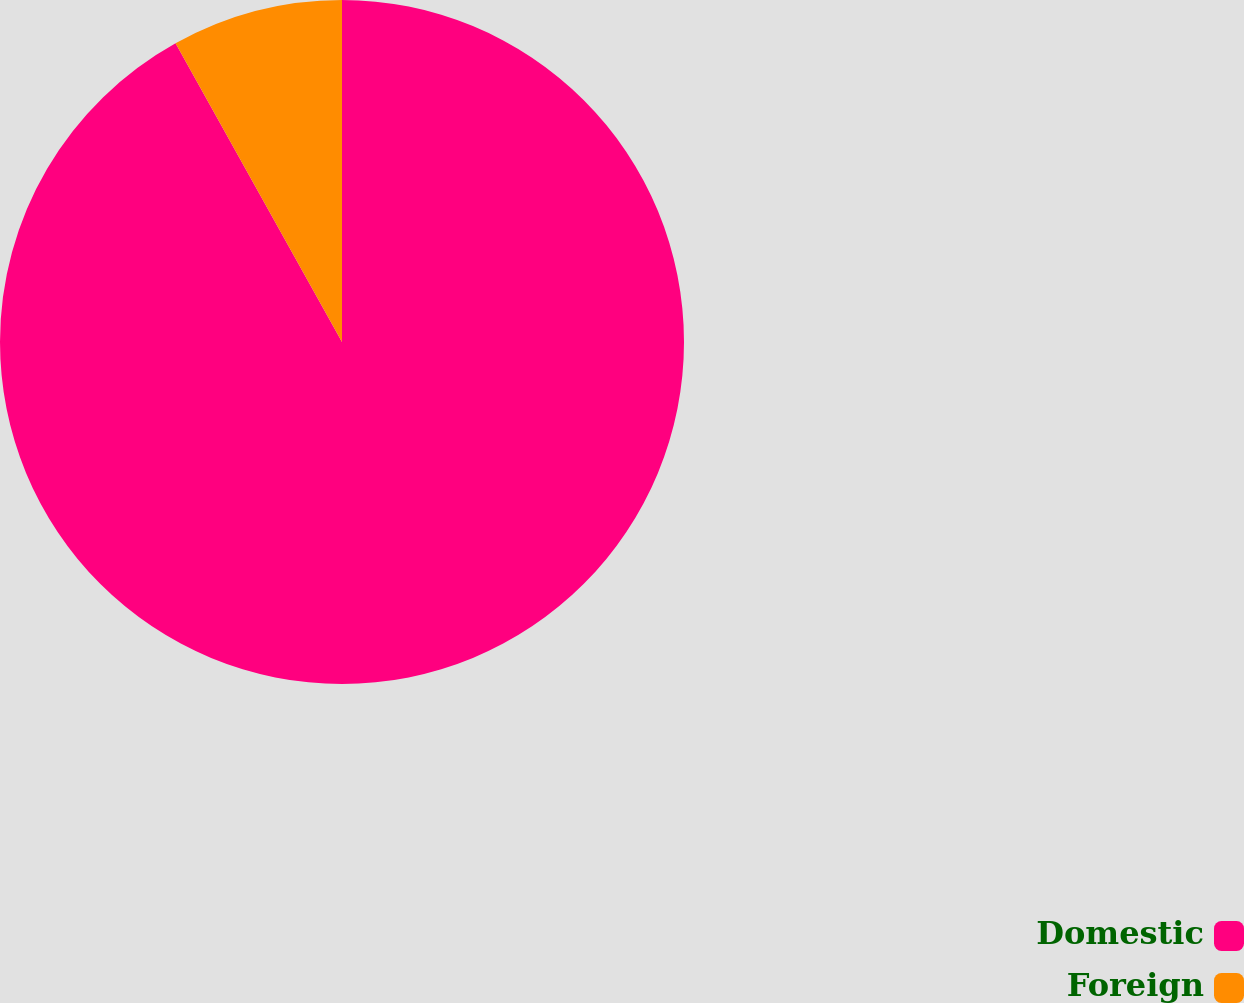<chart> <loc_0><loc_0><loc_500><loc_500><pie_chart><fcel>Domestic<fcel>Foreign<nl><fcel>91.91%<fcel>8.09%<nl></chart> 